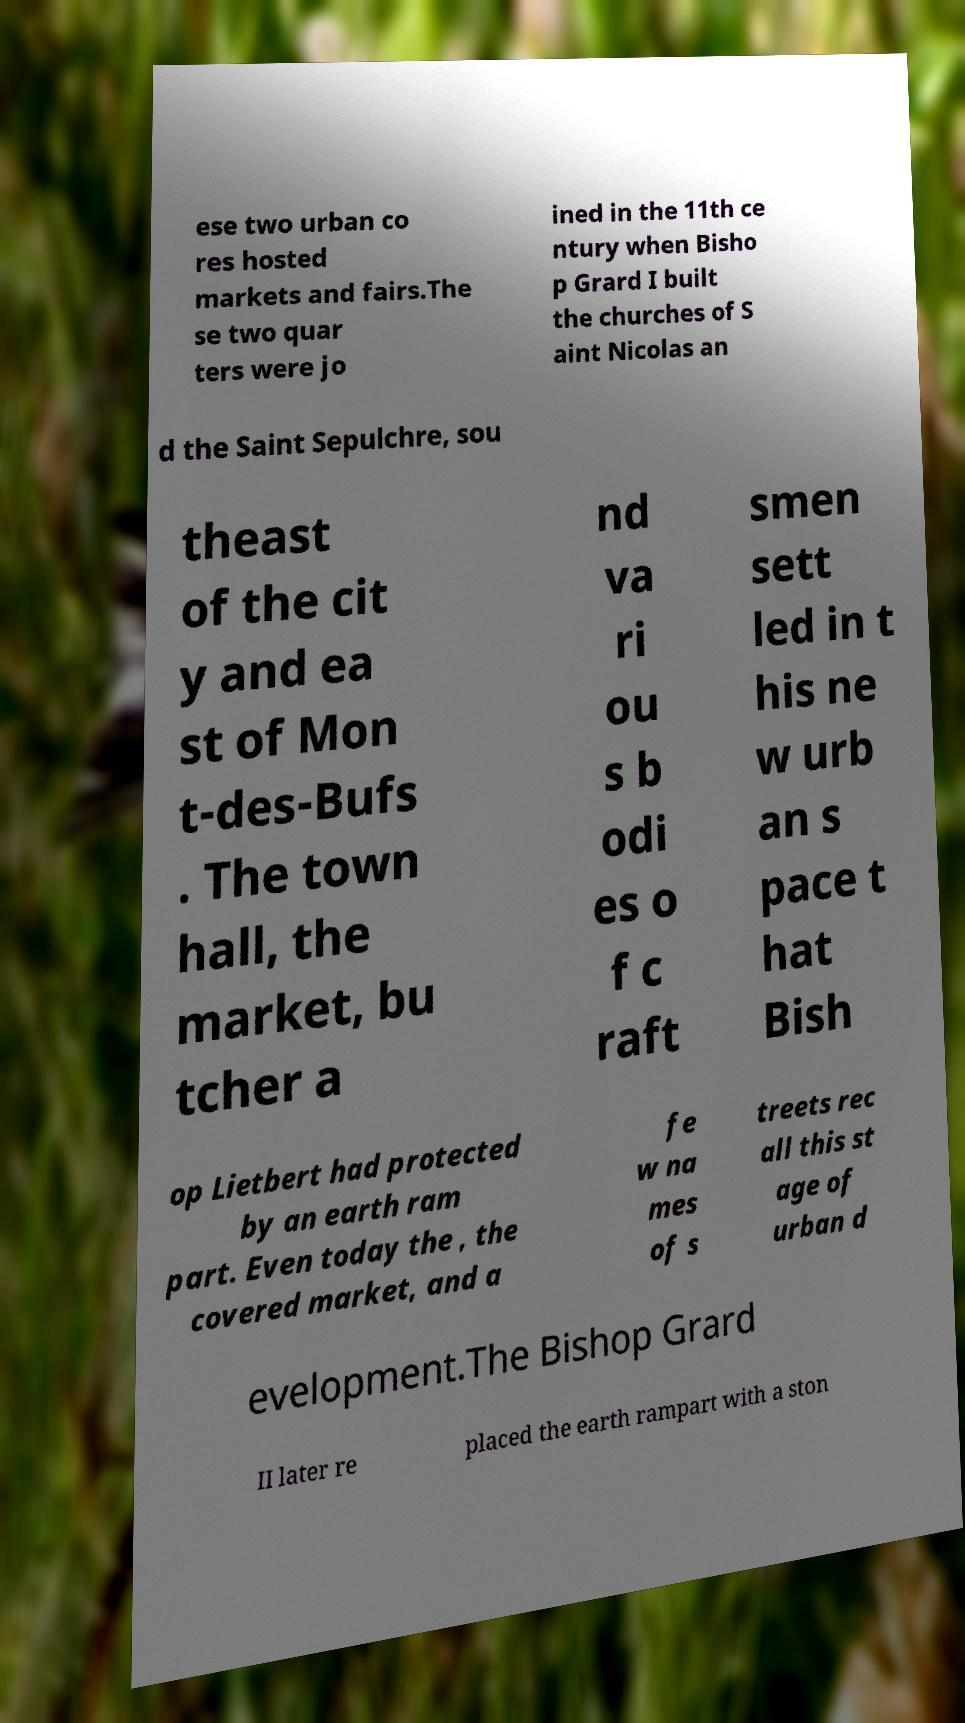Could you assist in decoding the text presented in this image and type it out clearly? ese two urban co res hosted markets and fairs.The se two quar ters were jo ined in the 11th ce ntury when Bisho p Grard I built the churches of S aint Nicolas an d the Saint Sepulchre, sou theast of the cit y and ea st of Mon t-des-Bufs . The town hall, the market, bu tcher a nd va ri ou s b odi es o f c raft smen sett led in t his ne w urb an s pace t hat Bish op Lietbert had protected by an earth ram part. Even today the , the covered market, and a fe w na mes of s treets rec all this st age of urban d evelopment.The Bishop Grard II later re placed the earth rampart with a ston 